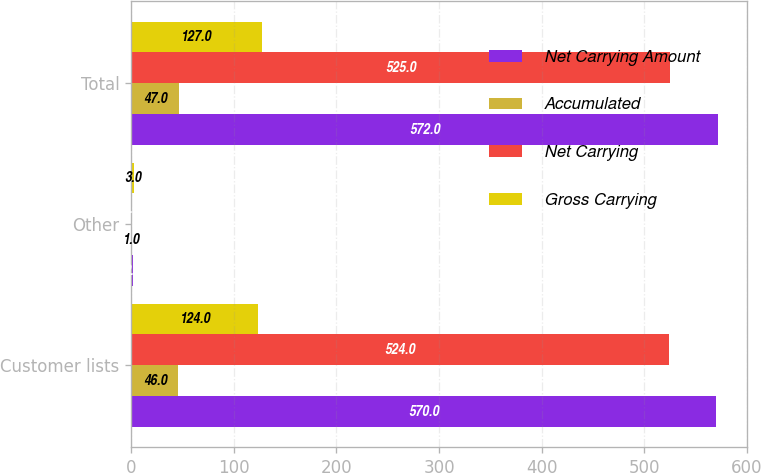Convert chart. <chart><loc_0><loc_0><loc_500><loc_500><stacked_bar_chart><ecel><fcel>Customer lists<fcel>Other<fcel>Total<nl><fcel>Net Carrying Amount<fcel>570<fcel>2<fcel>572<nl><fcel>Accumulated<fcel>46<fcel>1<fcel>47<nl><fcel>Net Carrying<fcel>524<fcel>1<fcel>525<nl><fcel>Gross Carrying<fcel>124<fcel>3<fcel>127<nl></chart> 